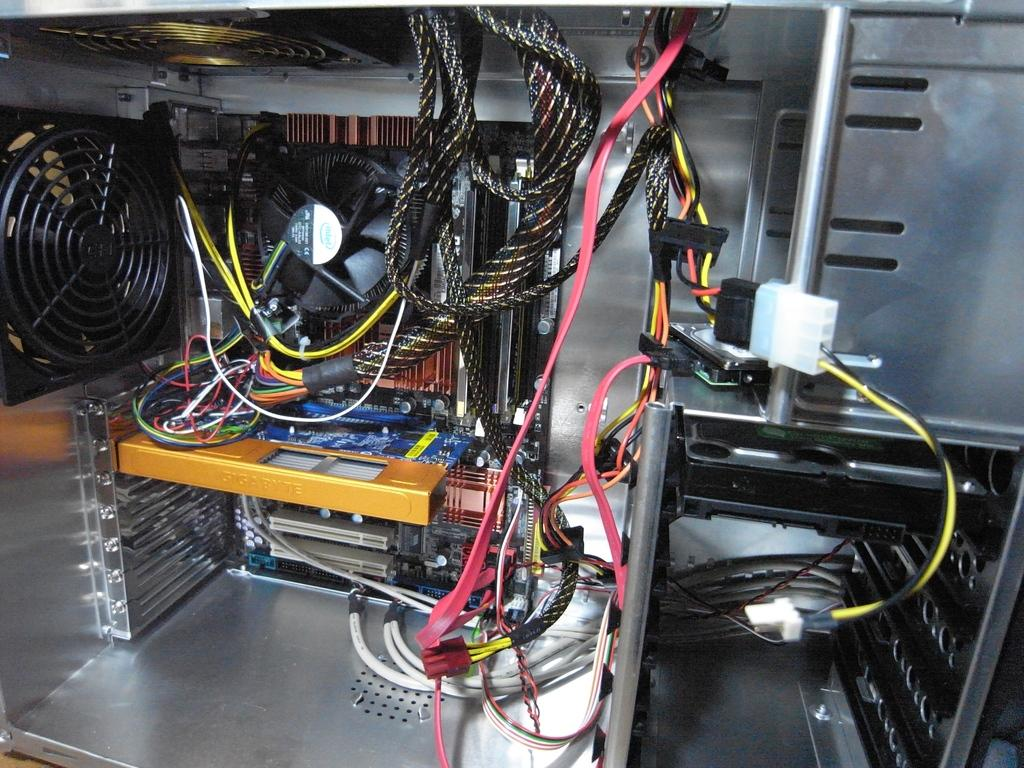What type of interior view is shown in the image? The image shows an interior view of a CPU. What components are visible in the image? There are fans, cable wires, a board, and some chips visible in the image. What might be used for cooling in the image? The fans visible in the image might be used for cooling. What type of connections might be present in the image? The cable wires visible in the image might be used for connections. What type of fog can be seen inside the CPU in the image? There is no fog visible inside the CPU in the image. Is there an airplane present in the image? No, there is no airplane present in the image; it shows an interior view of a CPU. 